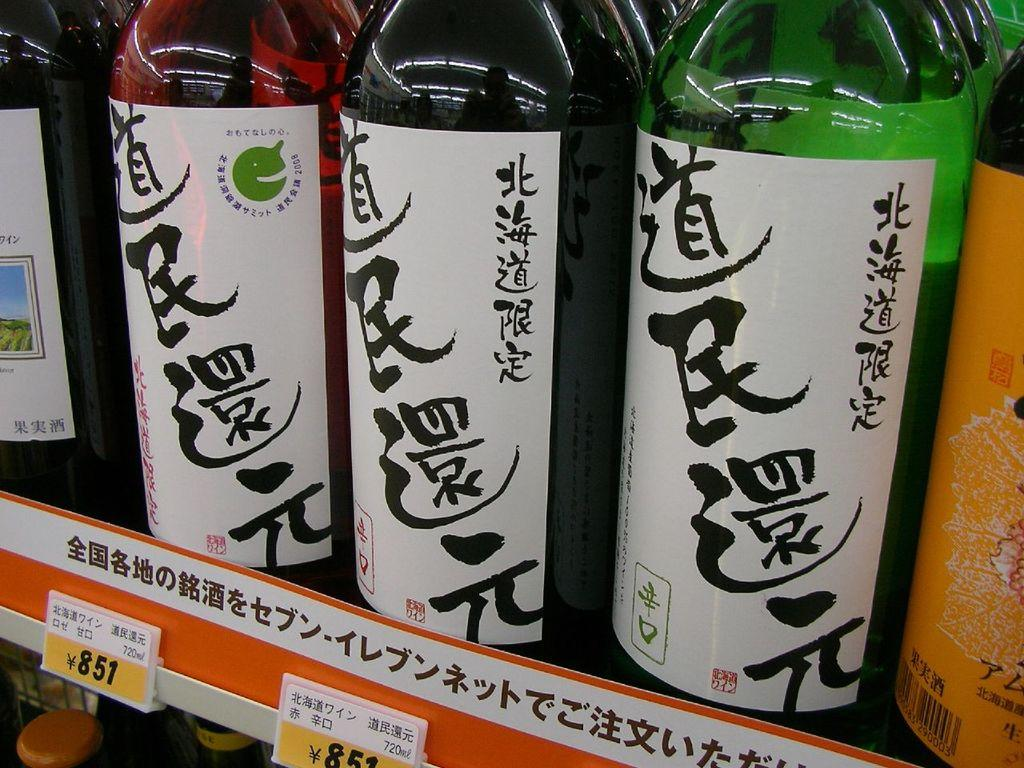<image>
Describe the image concisely. Multiple bottles of a drink for 851 Yen. 